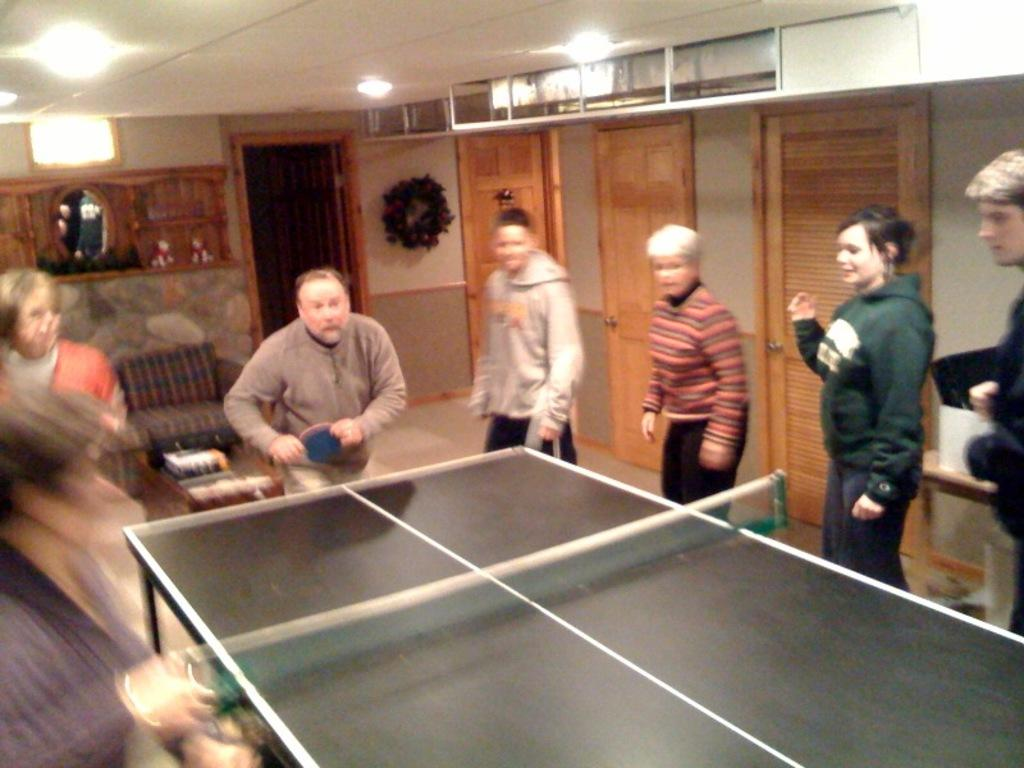How many people are present in the image? There are many people standing in the image. What activity is one person engaged in? One person is playing table tennis. What can be seen in the background of the image? There is a chair, doors, and a light visible in the background. What type of oil is being used by the person playing table tennis in the image? There is no oil present in the image, and the person playing table tennis is not using any oil. 